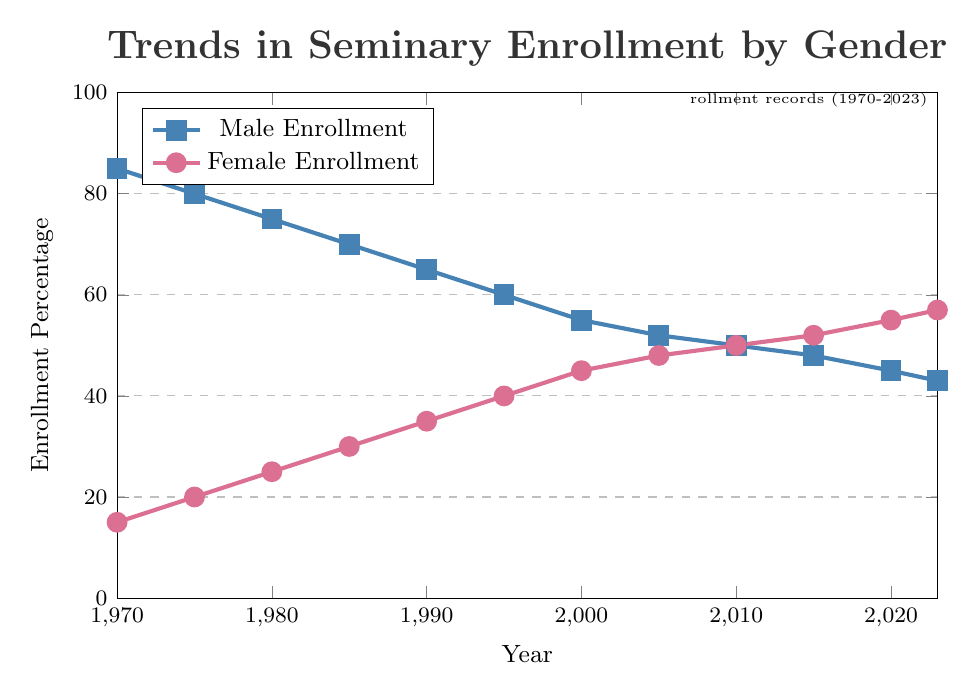How did male enrollment change from 1970 to 2023? Identify the male enrollment percentage in 1970 and 2023. It decreases from 85% in 1970 to 43% in 2023.
Answer: It decreased by 42 percentage points What is the trend in female enrollment between 1970 and 2023? Observe the female enrollment percentage in 1970 (15%) and in 2023 (57%). It shows a steady increase.
Answer: It increased by 42 percentage points Between which years did male and female enrollment reach parity? Look for the year where both enrollment percentages meet or cross. They are equal (both at 50%) in 2010.
Answer: 2010 By how much did the female enrollment percentage change between 1970 and 2000? Subtract the percentage in 1970 (15%) from the percentage in 2000 (45%). The increase is 45 - 15 = 30.
Answer: 30 percentage points Which year had the highest female enrollment percentage? Identify the year with the highest point on the female enrollment line. The final year on the plot, 2023, has the highest female enrollment at 57%.
Answer: 2023 What is the difference in male and female enrollment in 2023? Subtract the female enrollment percentage in 2023 (57%) from the male (43%). The difference is 57 - 43 = 14.
Answer: 14 percentage points How does the male enrollment in 1985 compare to the female enrollment in the same year? Find the male enrollment percentage (70%) and the female enrollment percentage (30%) in 1985. Male enrollment is higher by 70 - 30 = 40 percentage points.
Answer: Male enrollment is higher by 40 percentage points What was the rate of change in female enrollment from 1995 to 2005? Calculate the differences in percentages (48% - 40%) and the difference in years (2005 - 1995). The rate of change is (48-40) / (2005-1995) = 8 / 10 = 0.8 percentage points per year.
Answer: 0.8 percentage points per year During which decade did the most significant decrease in male enrollment occur? Observe the decrease between each decade. The largest decrease appears between 1970 and 1980, from 85% to 75%, a reduction of 10 percentage points.
Answer: 1970 to 1980 